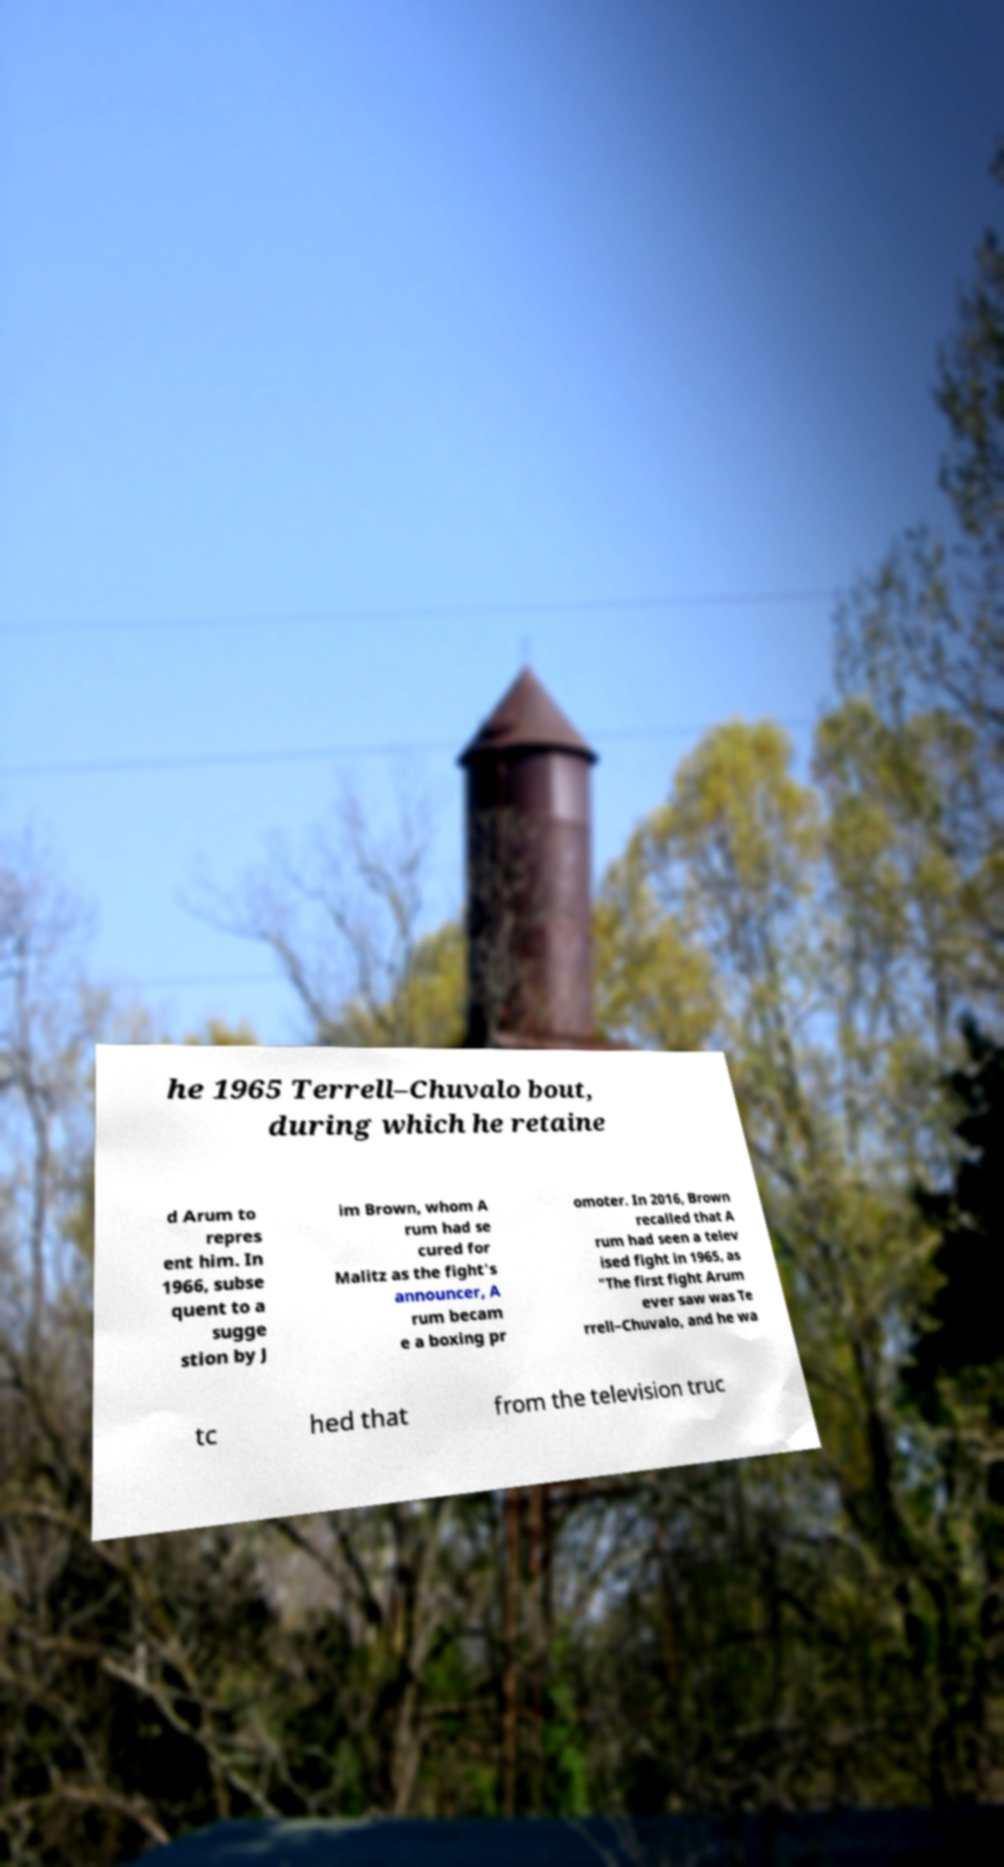Can you read and provide the text displayed in the image?This photo seems to have some interesting text. Can you extract and type it out for me? he 1965 Terrell–Chuvalo bout, during which he retaine d Arum to repres ent him. In 1966, subse quent to a sugge stion by J im Brown, whom A rum had se cured for Malitz as the fight's announcer, A rum becam e a boxing pr omoter. In 2016, Brown recalled that A rum had seen a telev ised fight in 1965, as "The first fight Arum ever saw was Te rrell–Chuvalo, and he wa tc hed that from the television truc 